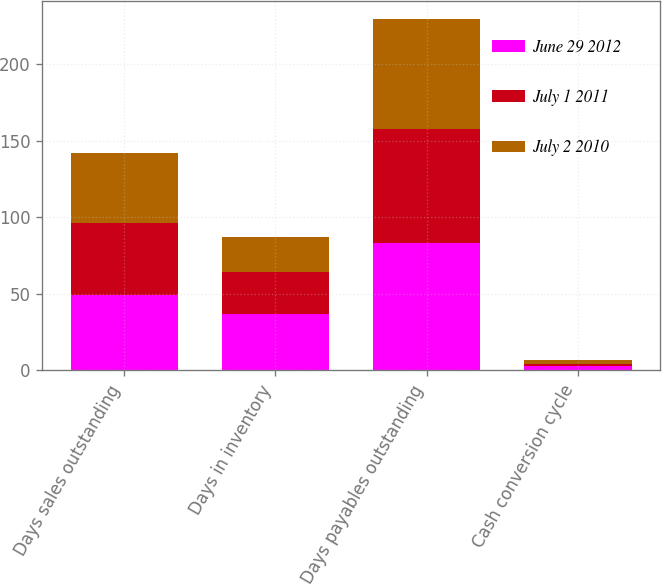Convert chart to OTSL. <chart><loc_0><loc_0><loc_500><loc_500><stacked_bar_chart><ecel><fcel>Days sales outstanding<fcel>Days in inventory<fcel>Days payables outstanding<fcel>Cash conversion cycle<nl><fcel>June 29 2012<fcel>49<fcel>37<fcel>83<fcel>3<nl><fcel>July 1 2011<fcel>47<fcel>27<fcel>75<fcel>1<nl><fcel>July 2 2010<fcel>46<fcel>23<fcel>72<fcel>3<nl></chart> 